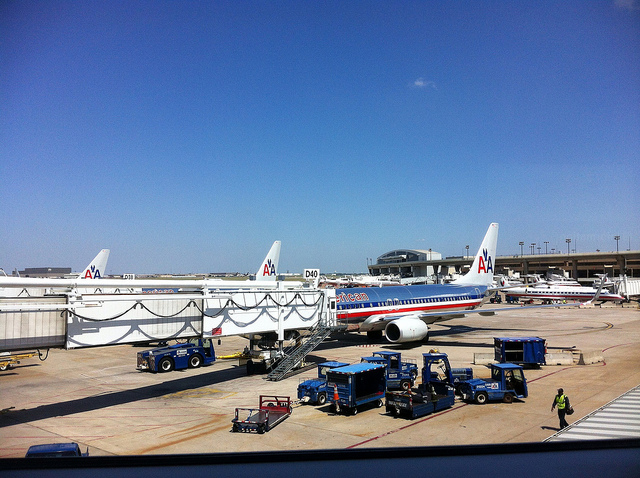Read and extract the text from this image. D40 AVA AA AVA 